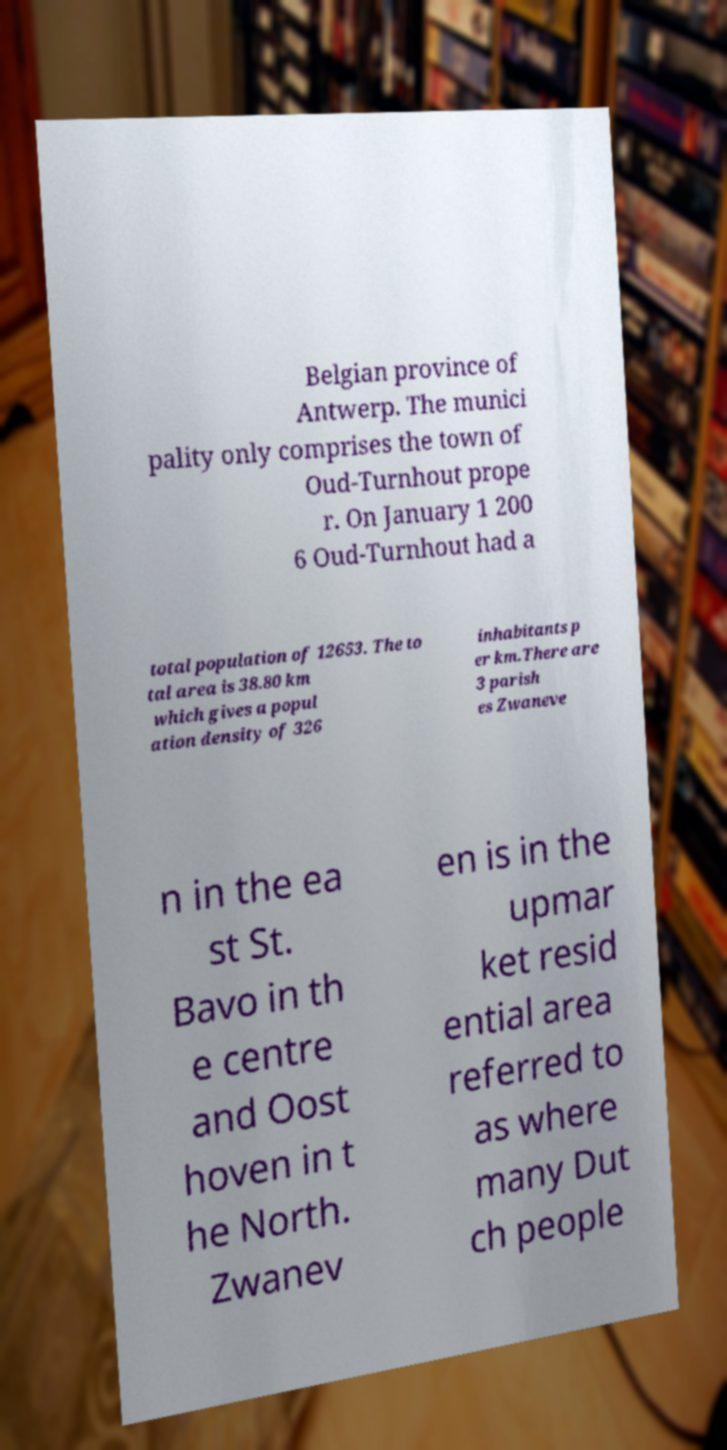Could you extract and type out the text from this image? Belgian province of Antwerp. The munici pality only comprises the town of Oud-Turnhout prope r. On January 1 200 6 Oud-Turnhout had a total population of 12653. The to tal area is 38.80 km which gives a popul ation density of 326 inhabitants p er km.There are 3 parish es Zwaneve n in the ea st St. Bavo in th e centre and Oost hoven in t he North. Zwanev en is in the upmar ket resid ential area referred to as where many Dut ch people 